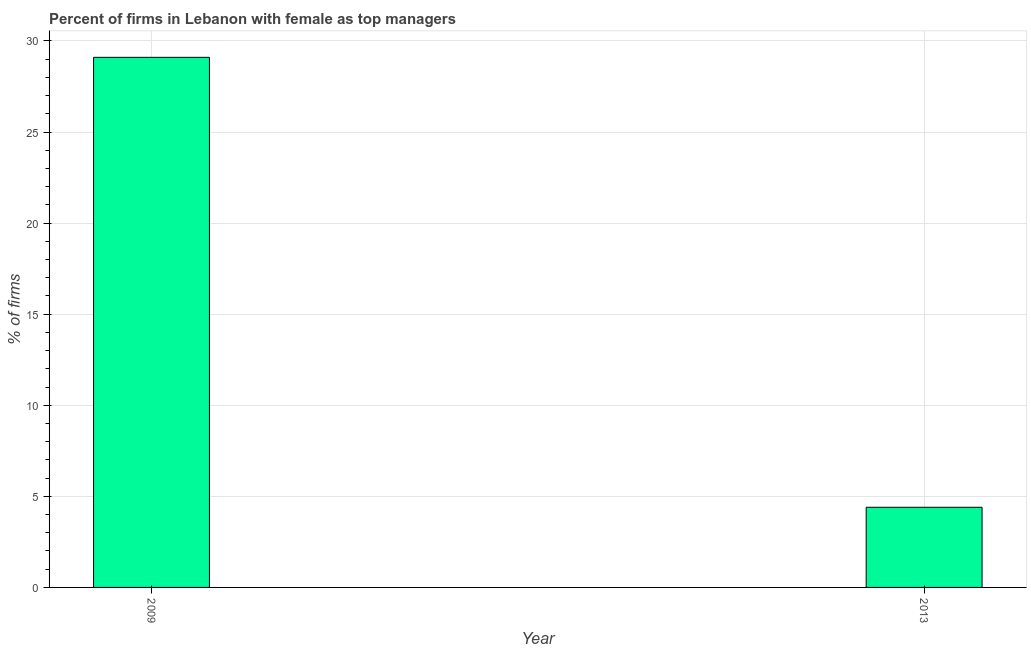Does the graph contain any zero values?
Keep it short and to the point. No. What is the title of the graph?
Your answer should be very brief. Percent of firms in Lebanon with female as top managers. What is the label or title of the Y-axis?
Offer a terse response. % of firms. What is the percentage of firms with female as top manager in 2013?
Offer a very short reply. 4.4. Across all years, what is the maximum percentage of firms with female as top manager?
Make the answer very short. 29.1. What is the sum of the percentage of firms with female as top manager?
Make the answer very short. 33.5. What is the difference between the percentage of firms with female as top manager in 2009 and 2013?
Your answer should be compact. 24.7. What is the average percentage of firms with female as top manager per year?
Make the answer very short. 16.75. What is the median percentage of firms with female as top manager?
Make the answer very short. 16.75. In how many years, is the percentage of firms with female as top manager greater than 8 %?
Ensure brevity in your answer.  1. Do a majority of the years between 2009 and 2013 (inclusive) have percentage of firms with female as top manager greater than 7 %?
Ensure brevity in your answer.  No. What is the ratio of the percentage of firms with female as top manager in 2009 to that in 2013?
Give a very brief answer. 6.61. What is the % of firms in 2009?
Provide a succinct answer. 29.1. What is the difference between the % of firms in 2009 and 2013?
Make the answer very short. 24.7. What is the ratio of the % of firms in 2009 to that in 2013?
Provide a succinct answer. 6.61. 